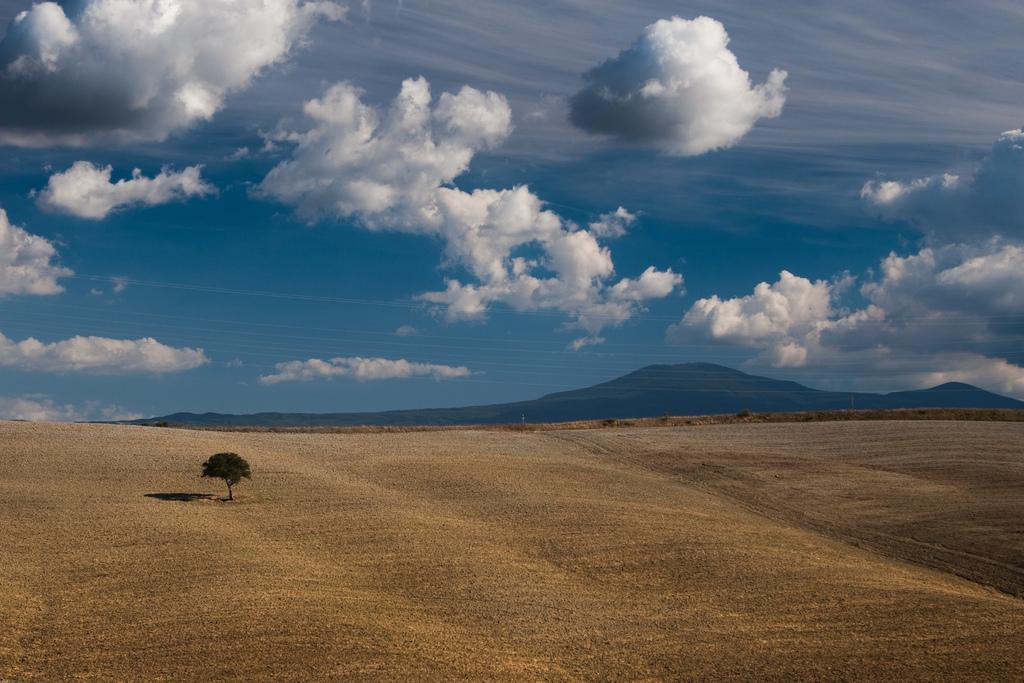How would you summarize this image in a sentence or two? In this image there are trees. At the bottom of the image there is sand on the surface. In the background of the image there are mountains. At the top of the image there are clouds in the sky. 